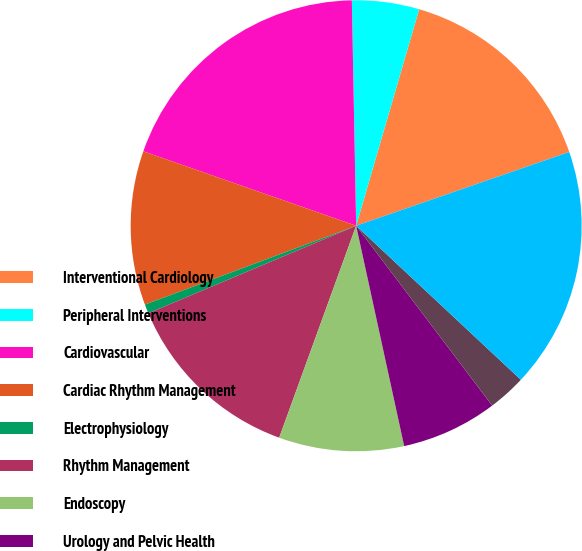Convert chart to OTSL. <chart><loc_0><loc_0><loc_500><loc_500><pie_chart><fcel>Interventional Cardiology<fcel>Peripheral Interventions<fcel>Cardiovascular<fcel>Cardiac Rhythm Management<fcel>Electrophysiology<fcel>Rhythm Management<fcel>Endoscopy<fcel>Urology and Pelvic Health<fcel>Neuromodulation<fcel>MedSurg<nl><fcel>15.19%<fcel>4.81%<fcel>19.34%<fcel>11.04%<fcel>0.66%<fcel>13.11%<fcel>8.96%<fcel>6.89%<fcel>2.73%<fcel>17.27%<nl></chart> 